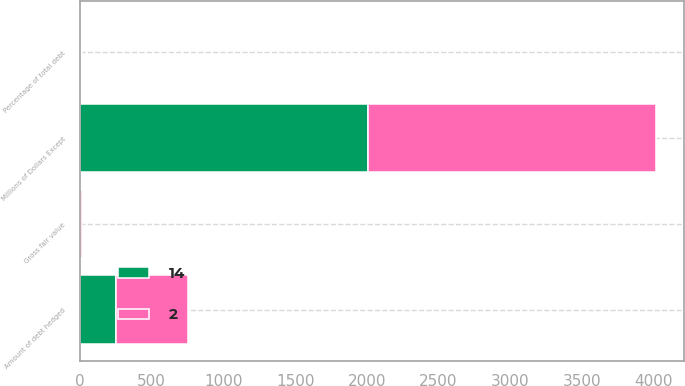<chart> <loc_0><loc_0><loc_500><loc_500><stacked_bar_chart><ecel><fcel>Millions of Dollars Except<fcel>Amount of debt hedged<fcel>Percentage of total debt<fcel>Gross fair value<nl><fcel>14<fcel>2007<fcel>250<fcel>3<fcel>2<nl><fcel>2<fcel>2006<fcel>500<fcel>7<fcel>14<nl></chart> 